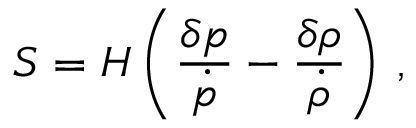Convert formula to latex. <formula><loc_0><loc_0><loc_500><loc_500>S = H \left ( { \frac { \delta p } { \dot { p } } } - { \frac { \delta \rho } { \dot { \rho } } } \right ) \, ,</formula> 